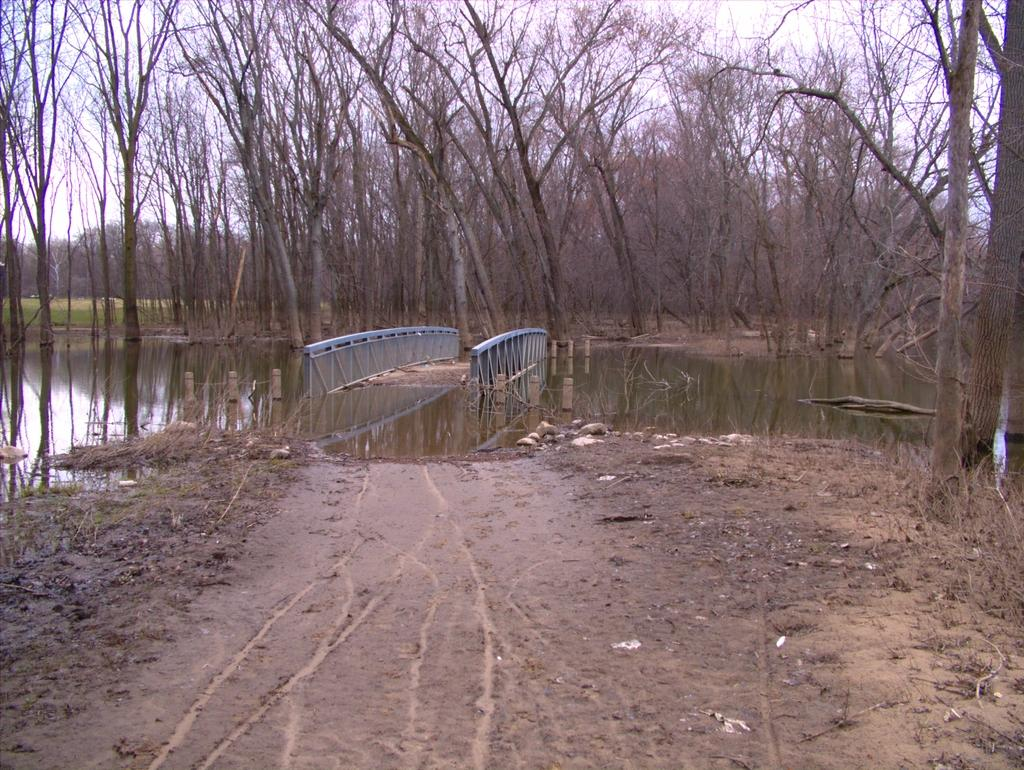What is the main structure in the center of the image? There is a metal bridge in the center of the image. What can be seen in the background of the image? There is a group of trees and the sky visible in the background of the image. What type of birthday celebration is happening on the bridge in the image? There is no birthday celebration or any indication of a celebration in the image; it only shows a metal bridge and a background with trees and the sky. 